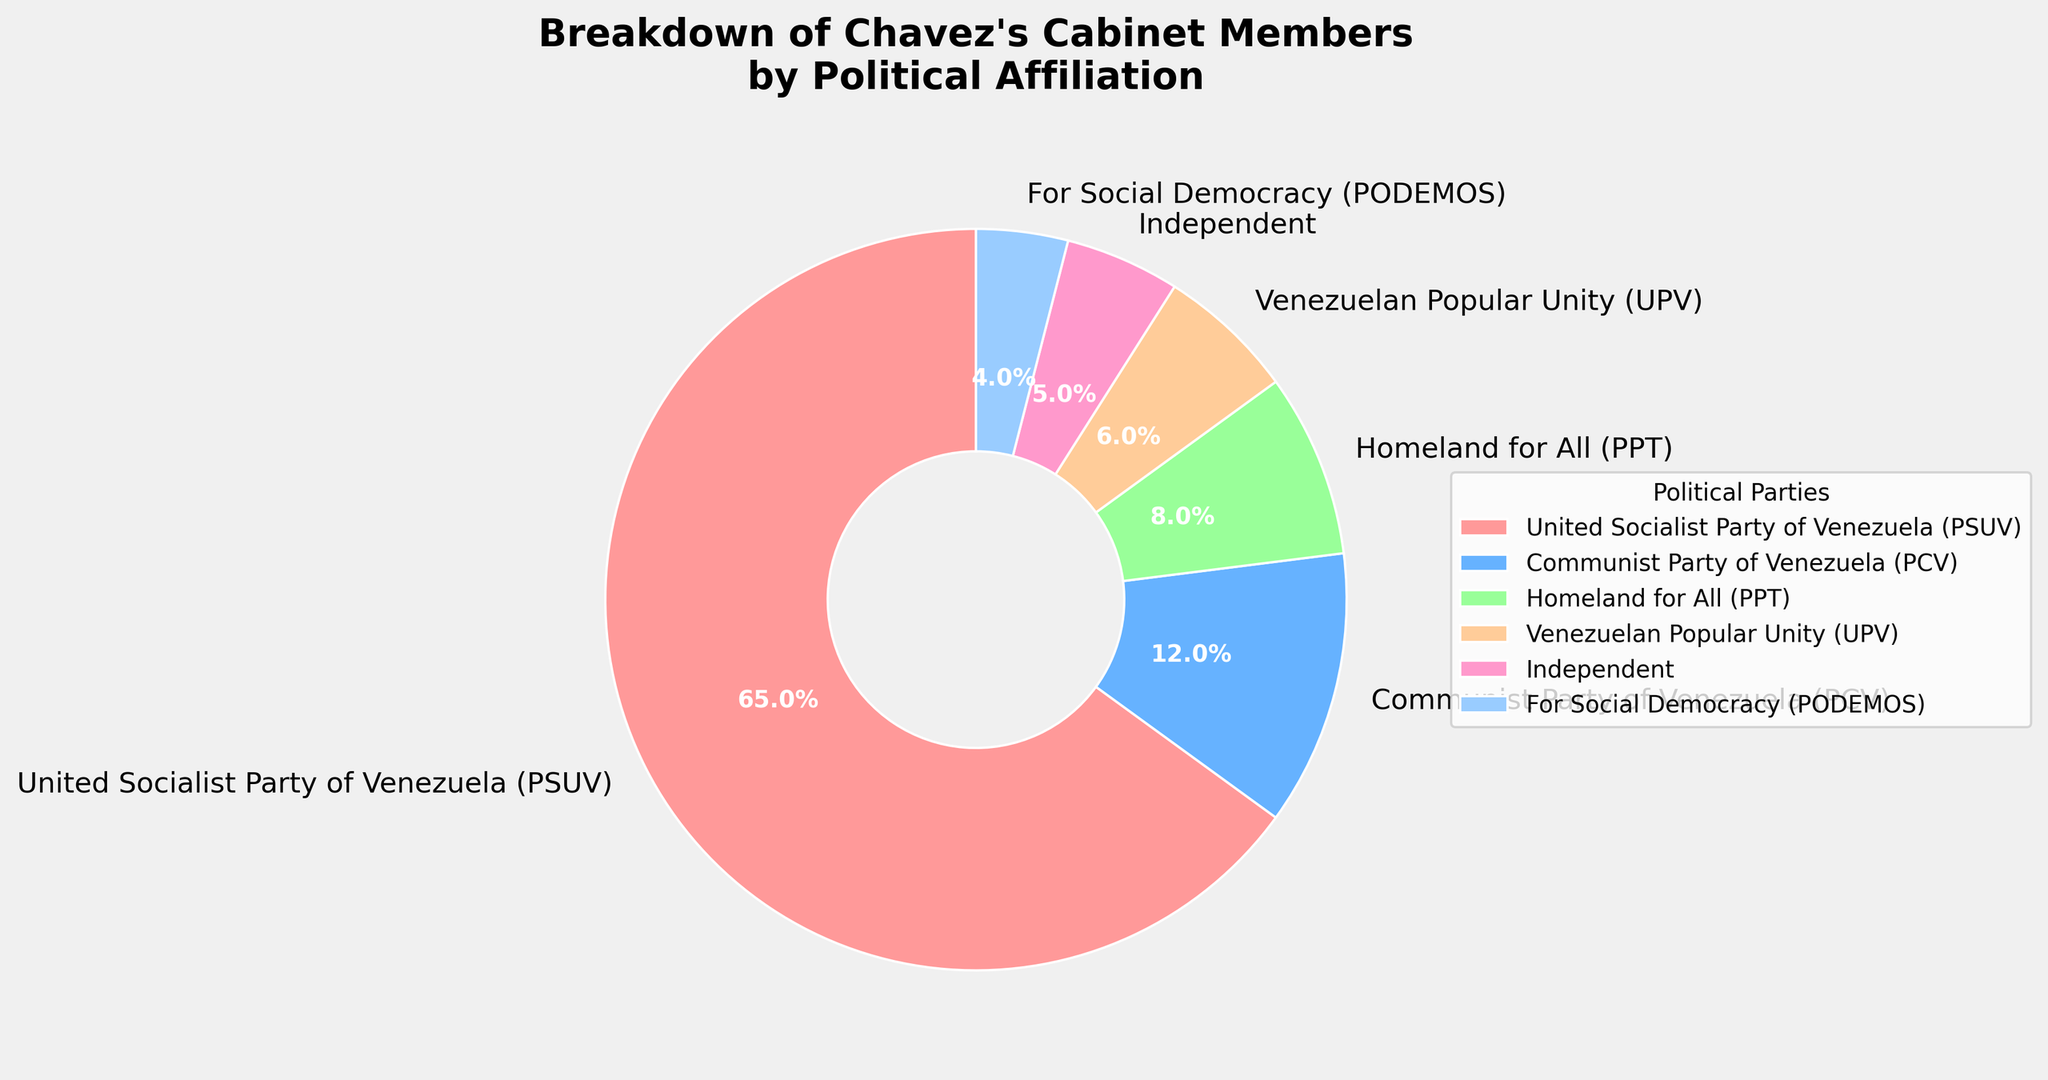What percentage of Chavez's cabinet members are not affiliated with the United Socialist Party of Venezuela (PSUV)? PSUV members constitute 65% of the cabinet. To find the percentage that is not PSUV, subtract 65% from 100%. 100% - 65% = 35%.
Answer: 35% Which political party has the second largest representation in Chavez's cabinet after the United Socialist Party of Venezuela (PSUV)? The PSUV is the largest with 65%. The next largest percentage is for the Communist Party of Venezuela (PCV) at 12%.
Answer: Communist Party of Venezuela (PCV) How much larger is the percentage of PSUV members compared to the combined percentage of PPT and UPV members in the cabinet? PSUV members make up 65%. PPT has 8% and UPV has 6%. Combined, PPT and UPV represent 8% + 6% = 14%. The difference is 65% - 14% = 51%.
Answer: 51% Is the percentage of Independent cabinet members greater than the combined percentage of PODEMOS and UPV members? Independent members make up 5%. PODEMOS has 4% and UPV has 6%. Combined, PODEMOS and UPV represent 4% + 6% = 10%. 5% is less than 10%.
Answer: No How many political parties have a representation of at least 10% in the cabinet? PSUV has 65% and PCV has 12%. These are the only parties with at least 10%. So, there are 2 parties.
Answer: Two What is the collective percentage of cabinet members from smaller parties (those with less than 10% representation individually)? Smaller parties include PPT (8%), UPV (6%), Independent (5%), and PODEMOS (4%). Adding these gives 8% + 6% + 5% + 4% = 23%.
Answer: 23% Which segment in the pie chart is represented by a green wedge? The colors given are for custom colors, with green for PPT. The PPT represents 8% of the cabinet.
Answer: PPT (Homeland for All) What is the absolute difference between the percentage of PSUV members and PCV members in the cabinet? PSUV holds 65% and PCV holds 12%. The absolute difference is 65% - 12% = 53%.
Answer: 53% Are Independent members more or less represented than the PCV members? Independent members make up 5%. The PCV members make up 12%. 5% is less than 12%.
Answer: Less Combine the percentages of the three smallest represented groups. What fraction of the total cabinet do they occupy? The three smallest groups are Independent (5%), PODEMOS (4%), and UPV (6%). Their combined percentage is 5% + 4% + 6% = 15%. Fraction of total = 15% / 100% = 15/100 = 3/20.
Answer: 3/20 